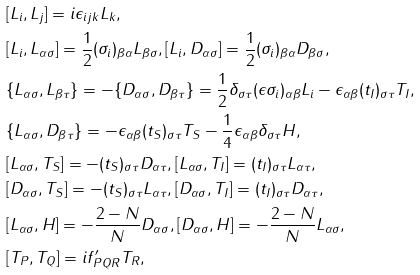<formula> <loc_0><loc_0><loc_500><loc_500>& [ L _ { i } , L _ { j } ] = i \epsilon _ { i j k } L _ { k } , \\ & [ L _ { i } , L _ { \alpha \sigma } ] = \frac { 1 } { 2 } ( \sigma _ { i } ) _ { \beta \alpha } L _ { \beta \sigma } , [ L _ { i } , D _ { \alpha \sigma } ] = \frac { 1 } { 2 } ( \sigma _ { i } ) _ { \beta \alpha } D _ { \beta \sigma } , \\ & \{ L _ { \alpha \sigma } , L _ { \beta \tau } \} = - \{ D _ { \alpha \sigma } , D _ { \beta \tau } \} = \frac { 1 } { 2 } \delta _ { \sigma \tau } ( \epsilon \sigma _ { i } ) _ { \alpha \beta } L _ { i } - \epsilon _ { \alpha \beta } ( t _ { I } ) _ { \sigma \tau } T _ { I } , \\ & \{ L _ { \alpha \sigma } , D _ { \beta \tau } \} = - \epsilon _ { \alpha \beta } ( t _ { S } ) _ { \sigma \tau } T _ { S } - \frac { 1 } { 4 } \epsilon _ { \alpha \beta } \delta _ { \sigma \tau } H , \\ & [ L _ { \alpha \sigma } , T _ { S } ] = - ( t _ { S } ) _ { \sigma \tau } D _ { \alpha \tau } , [ L _ { \alpha \sigma } , T _ { I } ] = ( t _ { I } ) _ { \sigma \tau } L _ { \alpha \tau } , \\ & [ D _ { \alpha \sigma } , T _ { S } ] = - ( t _ { S } ) _ { \sigma \tau } L _ { \alpha \tau } , [ D _ { \alpha \sigma } , T _ { I } ] = ( t _ { I } ) _ { \sigma \tau } D _ { \alpha \tau } , \\ & [ L _ { \alpha \sigma } , H ] = - \frac { 2 - N } { N } D _ { \alpha \sigma } , [ D _ { \alpha \sigma } , H ] = - \frac { 2 - N } { N } L _ { \alpha \sigma } , \\ & [ T _ { P } , T _ { Q } ] = i f ^ { \prime } _ { P Q R } T _ { R } ,</formula> 